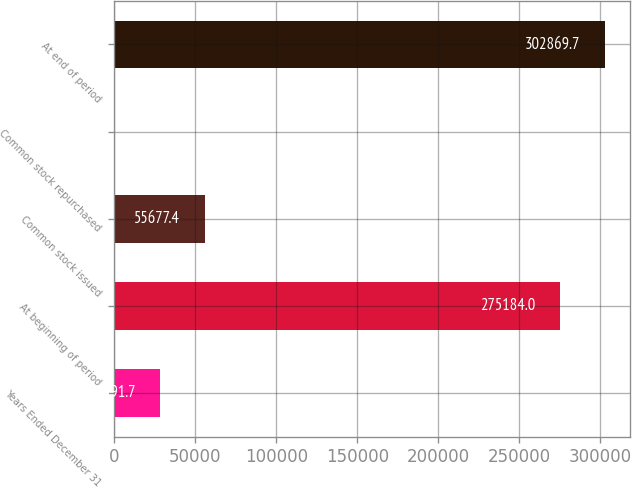Convert chart. <chart><loc_0><loc_0><loc_500><loc_500><bar_chart><fcel>Years Ended December 31<fcel>At beginning of period<fcel>Common stock issued<fcel>Common stock repurchased<fcel>At end of period<nl><fcel>27991.7<fcel>275184<fcel>55677.4<fcel>306<fcel>302870<nl></chart> 